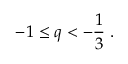<formula> <loc_0><loc_0><loc_500><loc_500>- 1 \leq q < - \frac { 1 } { 3 } \, .</formula> 